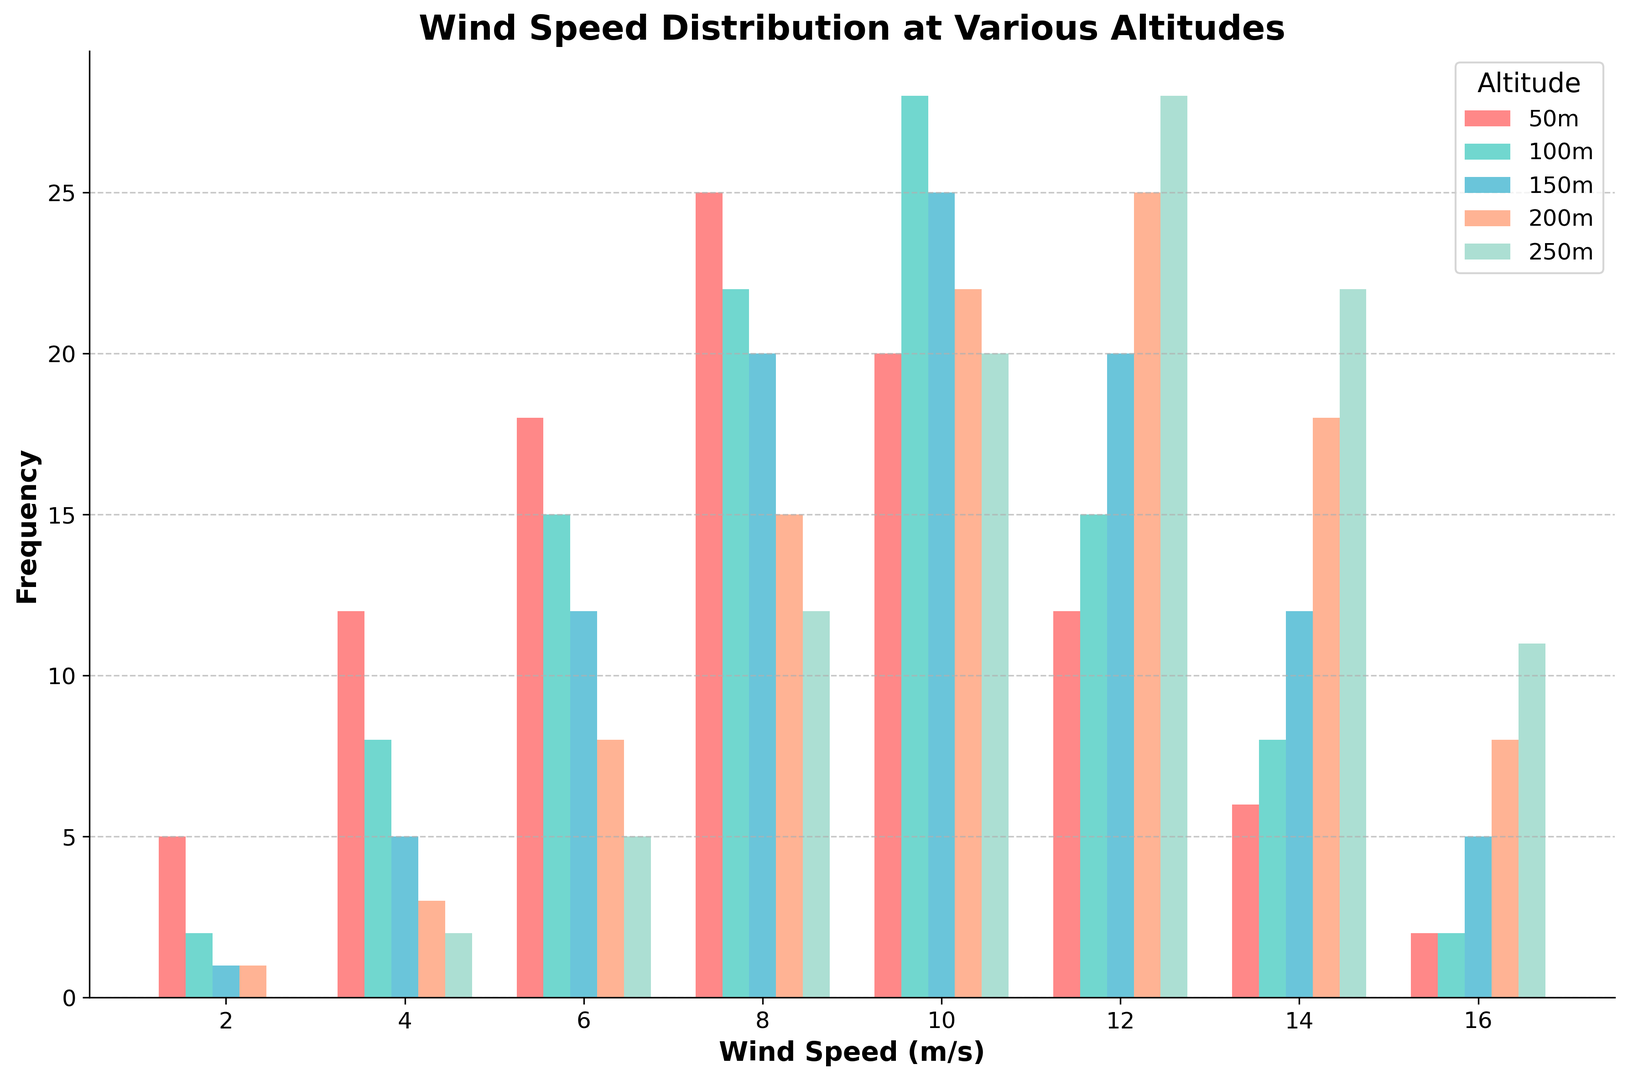What altitude has the overall highest frequency of wind speeds between 8-10 m/s? By looking at the bars for each altitude, we see that 250 meters has the highest bar for the 8-10 m/s wind speed range.
Answer: 250 meters Which altitude has the most consistent distribution of wind speeds? Evaluate the variability of the frequencies across wind speeds for each altitude. 50, 100, and 150 meters show variation, but 200 meters has a relatively evenly distributed set of frequencies across the wind speeds.
Answer: 200 meters What is the frequency of wind speeds at 6-8 m/s for 50 meters? Identify the bar corresponding to the 6-8 m/s wind speed at 50 meters and read its height.
Answer: 25 How does the frequency of wind speeds 10-12 m/s at 100 meters compare to 250 meters? Compare the heights of the bars representing the 10-12 m/s wind speed at 100 meters and 250 meters. 250 meters has a higher bar.
Answer: 250 meters is higher What is the sum of frequencies for wind speeds greater than 10 m/s at 150 meters? Sum the heights of the bars for the 10-12 m/s and 12-14 m/s wind speeds at 150 meters. Frequencies are 20 and 12, respectively.
Answer: 32 Which wind speed range has the highest overall frequency across all altitudes? For each wind speed range, sum up the frequencies across all altitudes and identify the highest sum. The 8-10 m/s range has the highest total frequency.
Answer: 8-10 m/s At 200 meters, what is the difference in frequency between wind speeds 6-8 m/s and 12-14 m/s? Subtract the frequency of the 6-8 m/s wind speed (15) from the frequency of the 12-14 m/s wind speed (18) at 200 meters.
Answer: 3 Is the frequency distribution of wind speeds at 150 meters bimodal? Check if there are two distinct high-frequency ranges at 150 meters. The histogram shows two peaks at 8-10 m/s and 10-12 m/s, indicating a bimodal distribution.
Answer: Yes What is the average frequency of wind speeds at 50 meters? Sum the frequencies at 50 meters and divide by the number of wind speed ranges. Sum = 5+12+18+25+20+12+6+2 = 100, number of ranges = 8.
Answer: 12.5 